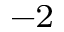Convert formula to latex. <formula><loc_0><loc_0><loc_500><loc_500>^ { - 2 }</formula> 